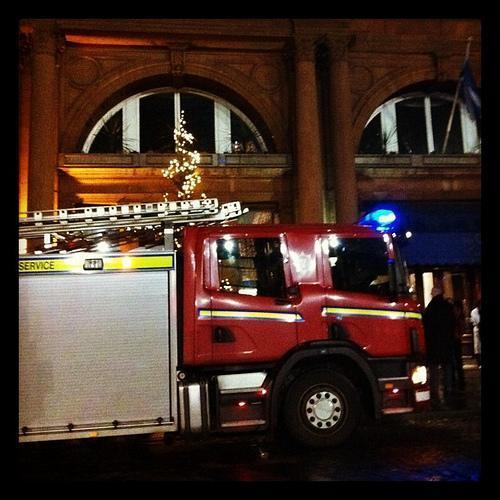How many trucks are there?
Give a very brief answer. 1. 